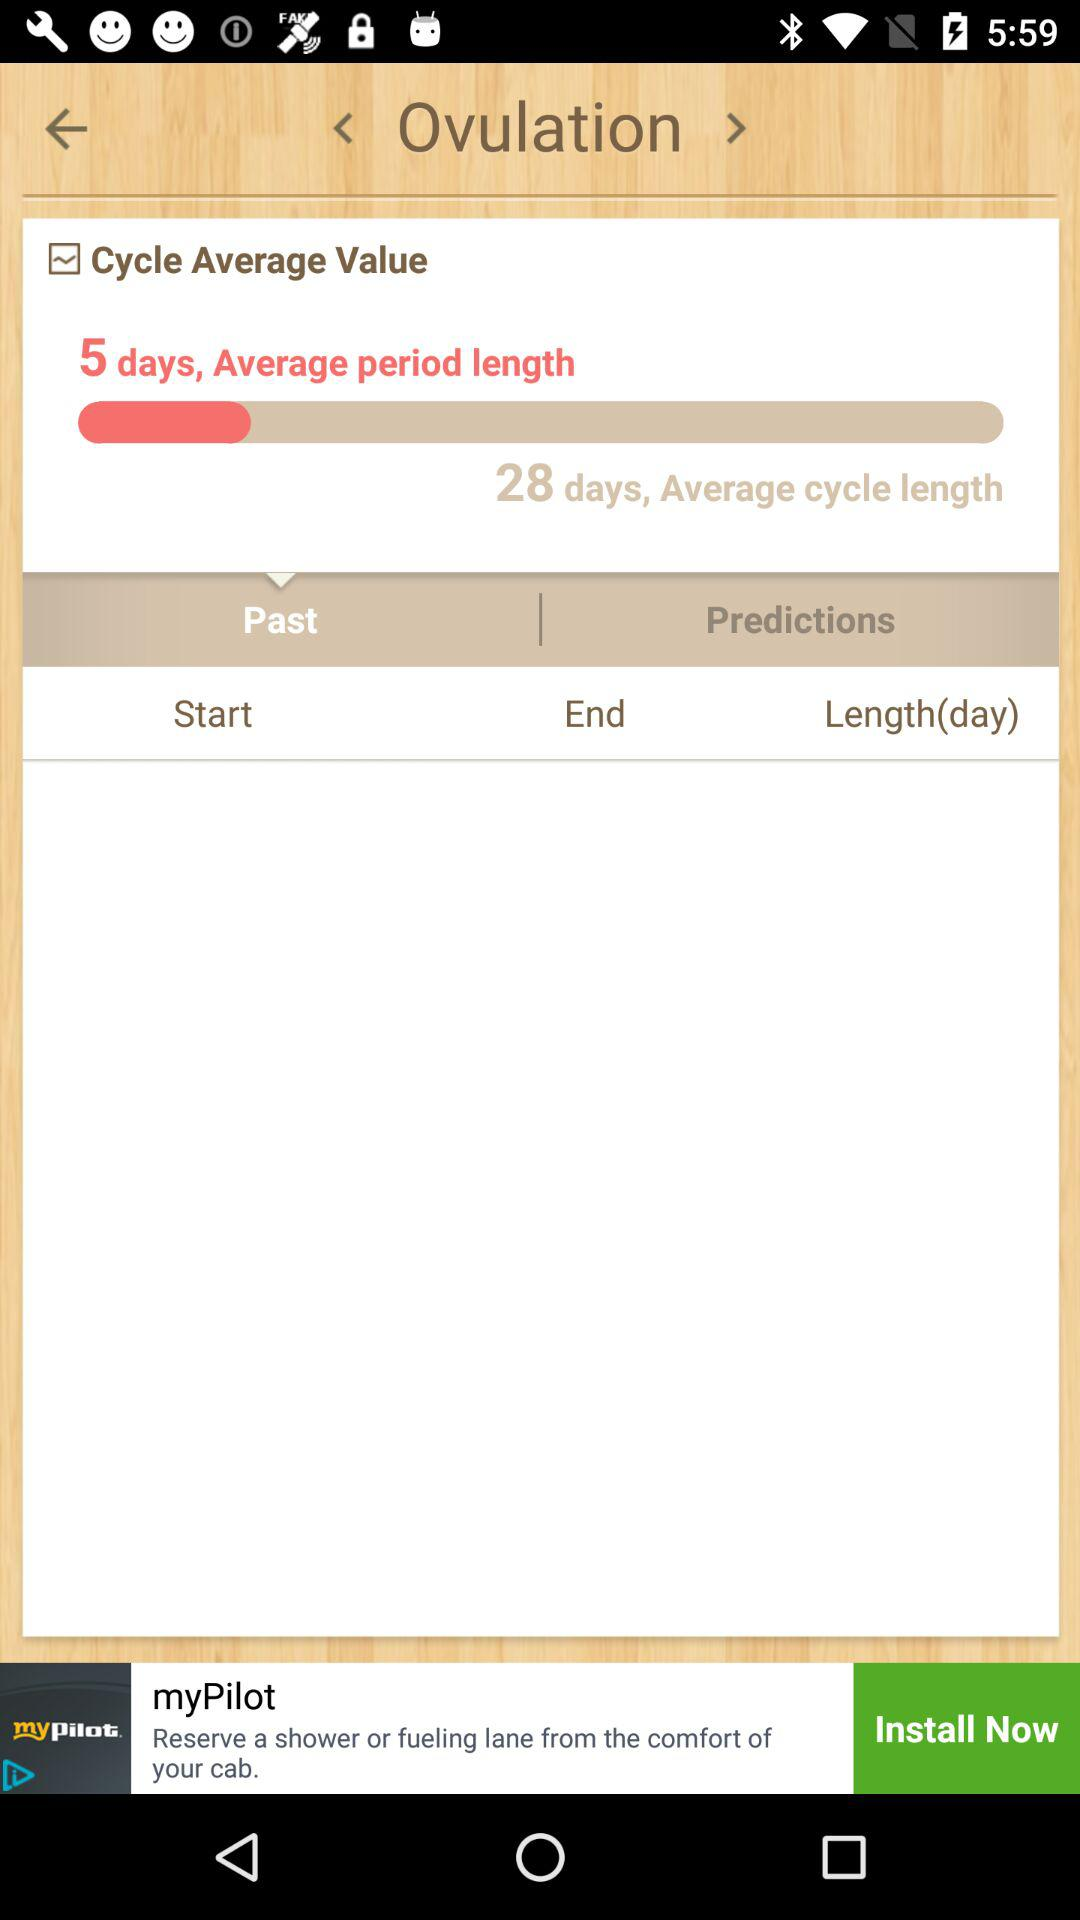How many days is the "Average period length"? The average period length is 5 days. 